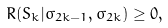Convert formula to latex. <formula><loc_0><loc_0><loc_500><loc_500>R ( S _ { k } | \sigma _ { 2 k - 1 } , \sigma _ { 2 k } ) \geq 0 ,</formula> 